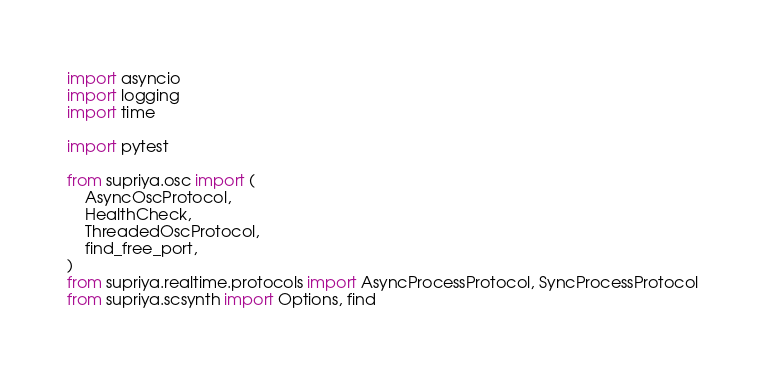Convert code to text. <code><loc_0><loc_0><loc_500><loc_500><_Python_>import asyncio
import logging
import time

import pytest

from supriya.osc import (
    AsyncOscProtocol,
    HealthCheck,
    ThreadedOscProtocol,
    find_free_port,
)
from supriya.realtime.protocols import AsyncProcessProtocol, SyncProcessProtocol
from supriya.scsynth import Options, find

</code> 